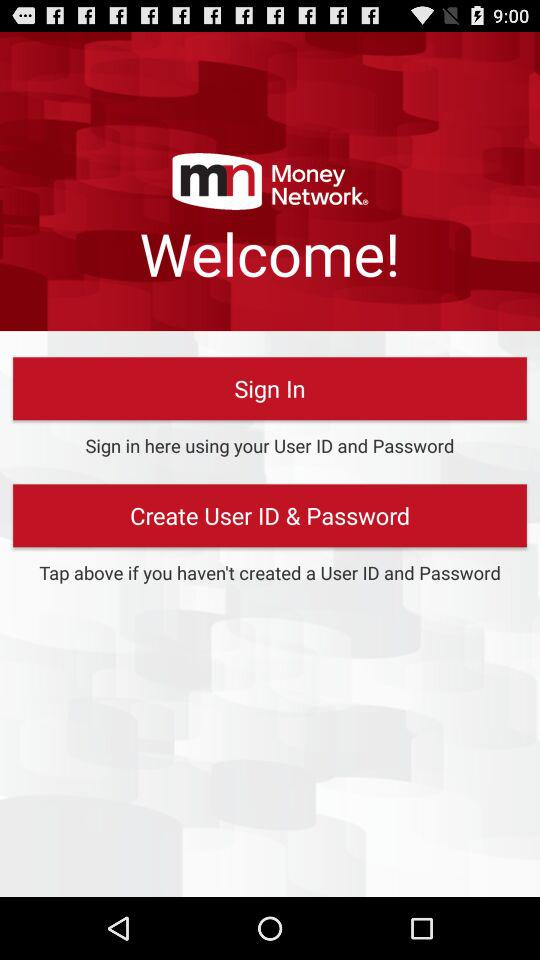What are the requirements to sign in? The requirements are "User ID" and "Password". 